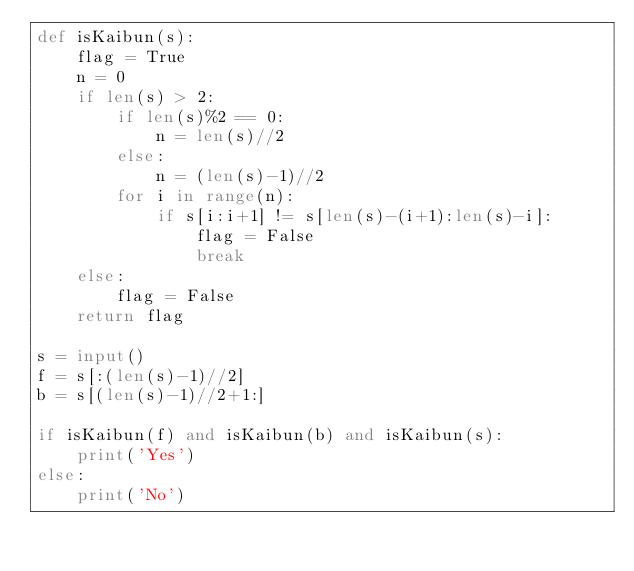Convert code to text. <code><loc_0><loc_0><loc_500><loc_500><_Python_>def isKaibun(s):
    flag = True
    n = 0
    if len(s) > 2:
        if len(s)%2 == 0:
            n = len(s)//2
        else:
            n = (len(s)-1)//2
        for i in range(n):
            if s[i:i+1] != s[len(s)-(i+1):len(s)-i]:
                flag = False
                break
    else:
        flag = False
    return flag
        
s = input()
f = s[:(len(s)-1)//2]
b = s[(len(s)-1)//2+1:]

if isKaibun(f) and isKaibun(b) and isKaibun(s):
    print('Yes')
else:
    print('No')</code> 